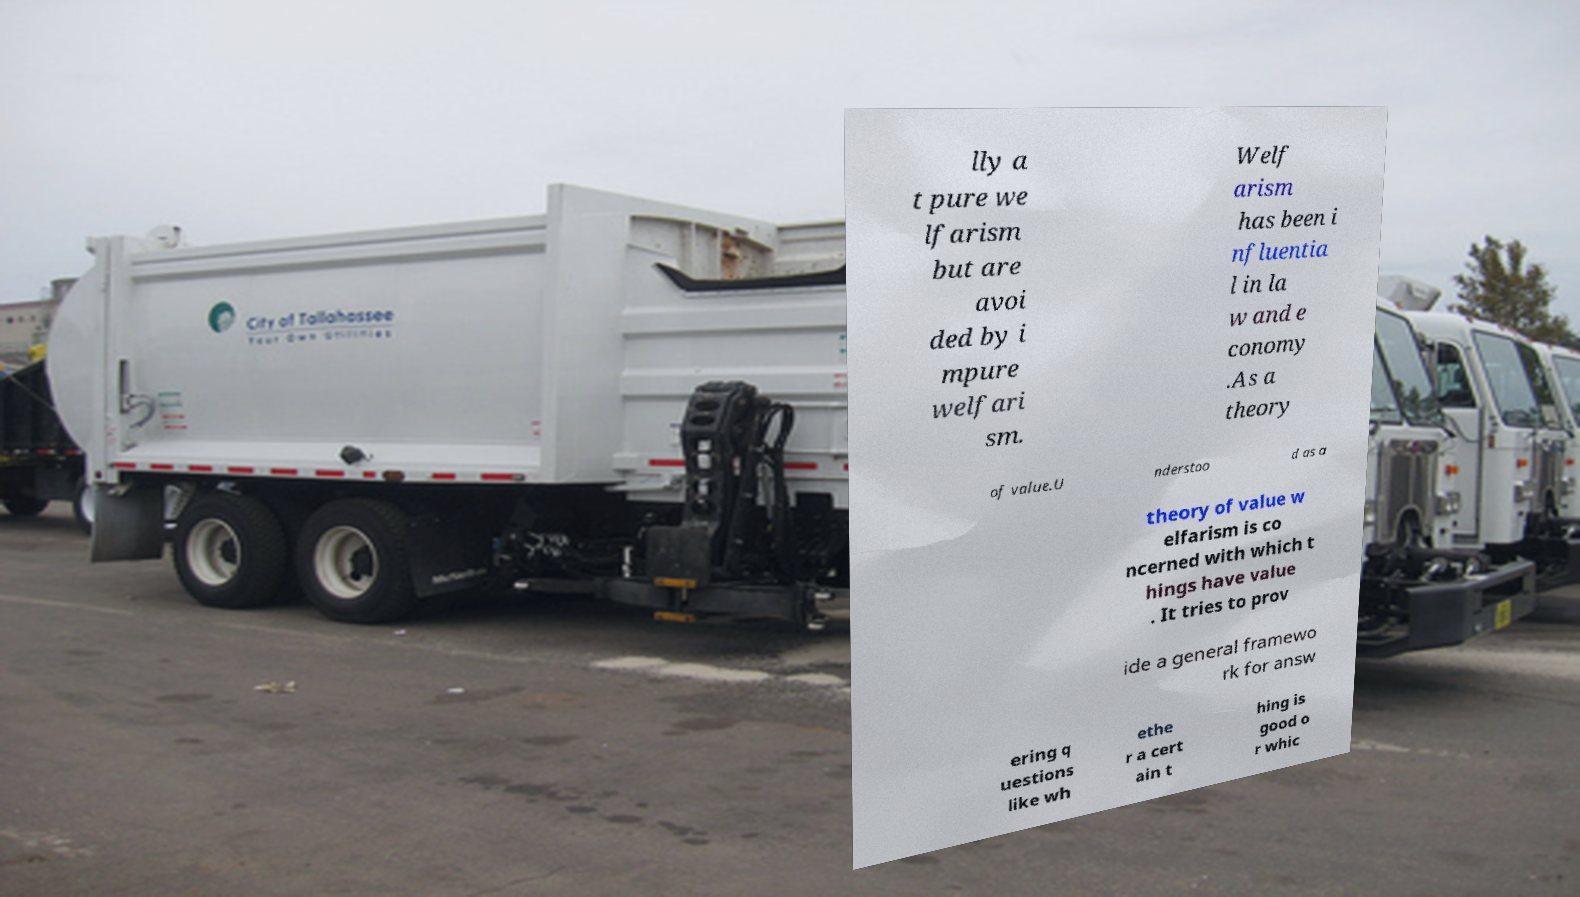Please read and relay the text visible in this image. What does it say? lly a t pure we lfarism but are avoi ded by i mpure welfari sm. Welf arism has been i nfluentia l in la w and e conomy .As a theory of value.U nderstoo d as a theory of value w elfarism is co ncerned with which t hings have value . It tries to prov ide a general framewo rk for answ ering q uestions like wh ethe r a cert ain t hing is good o r whic 